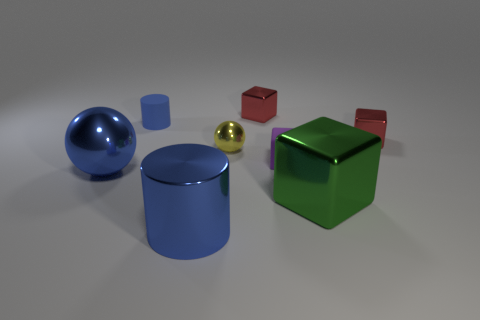Add 1 purple rubber cubes. How many objects exist? 9 Subtract all balls. How many objects are left? 6 Add 3 big green objects. How many big green objects exist? 4 Subtract 0 blue blocks. How many objects are left? 8 Subtract all green metal objects. Subtract all big blue shiny cylinders. How many objects are left? 6 Add 4 cubes. How many cubes are left? 8 